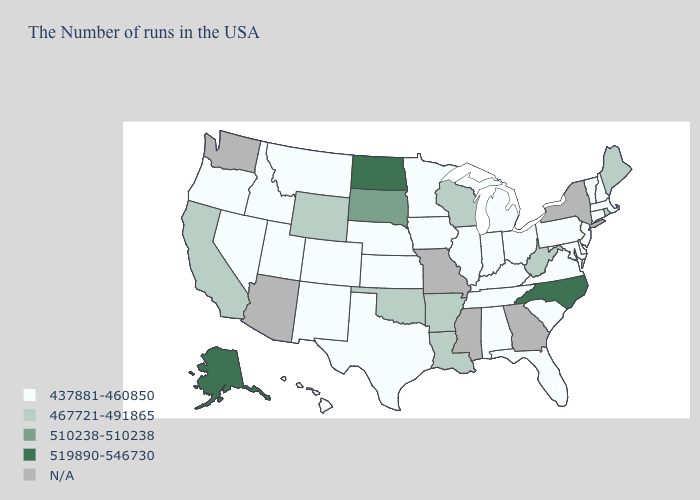Is the legend a continuous bar?
Concise answer only. No. What is the highest value in the South ?
Concise answer only. 519890-546730. Among the states that border North Carolina , which have the highest value?
Answer briefly. Virginia, South Carolina, Tennessee. Does California have the lowest value in the West?
Short answer required. No. What is the highest value in the USA?
Give a very brief answer. 519890-546730. Does Nebraska have the lowest value in the MidWest?
Write a very short answer. Yes. Among the states that border Kansas , does Nebraska have the lowest value?
Give a very brief answer. Yes. Which states have the lowest value in the South?
Give a very brief answer. Delaware, Maryland, Virginia, South Carolina, Florida, Kentucky, Alabama, Tennessee, Texas. Name the states that have a value in the range 510238-510238?
Be succinct. South Dakota. What is the value of Tennessee?
Give a very brief answer. 437881-460850. Among the states that border Idaho , does Wyoming have the lowest value?
Give a very brief answer. No. What is the value of Minnesota?
Write a very short answer. 437881-460850. Name the states that have a value in the range 437881-460850?
Quick response, please. Massachusetts, New Hampshire, Vermont, Connecticut, New Jersey, Delaware, Maryland, Pennsylvania, Virginia, South Carolina, Ohio, Florida, Michigan, Kentucky, Indiana, Alabama, Tennessee, Illinois, Minnesota, Iowa, Kansas, Nebraska, Texas, Colorado, New Mexico, Utah, Montana, Idaho, Nevada, Oregon, Hawaii. 